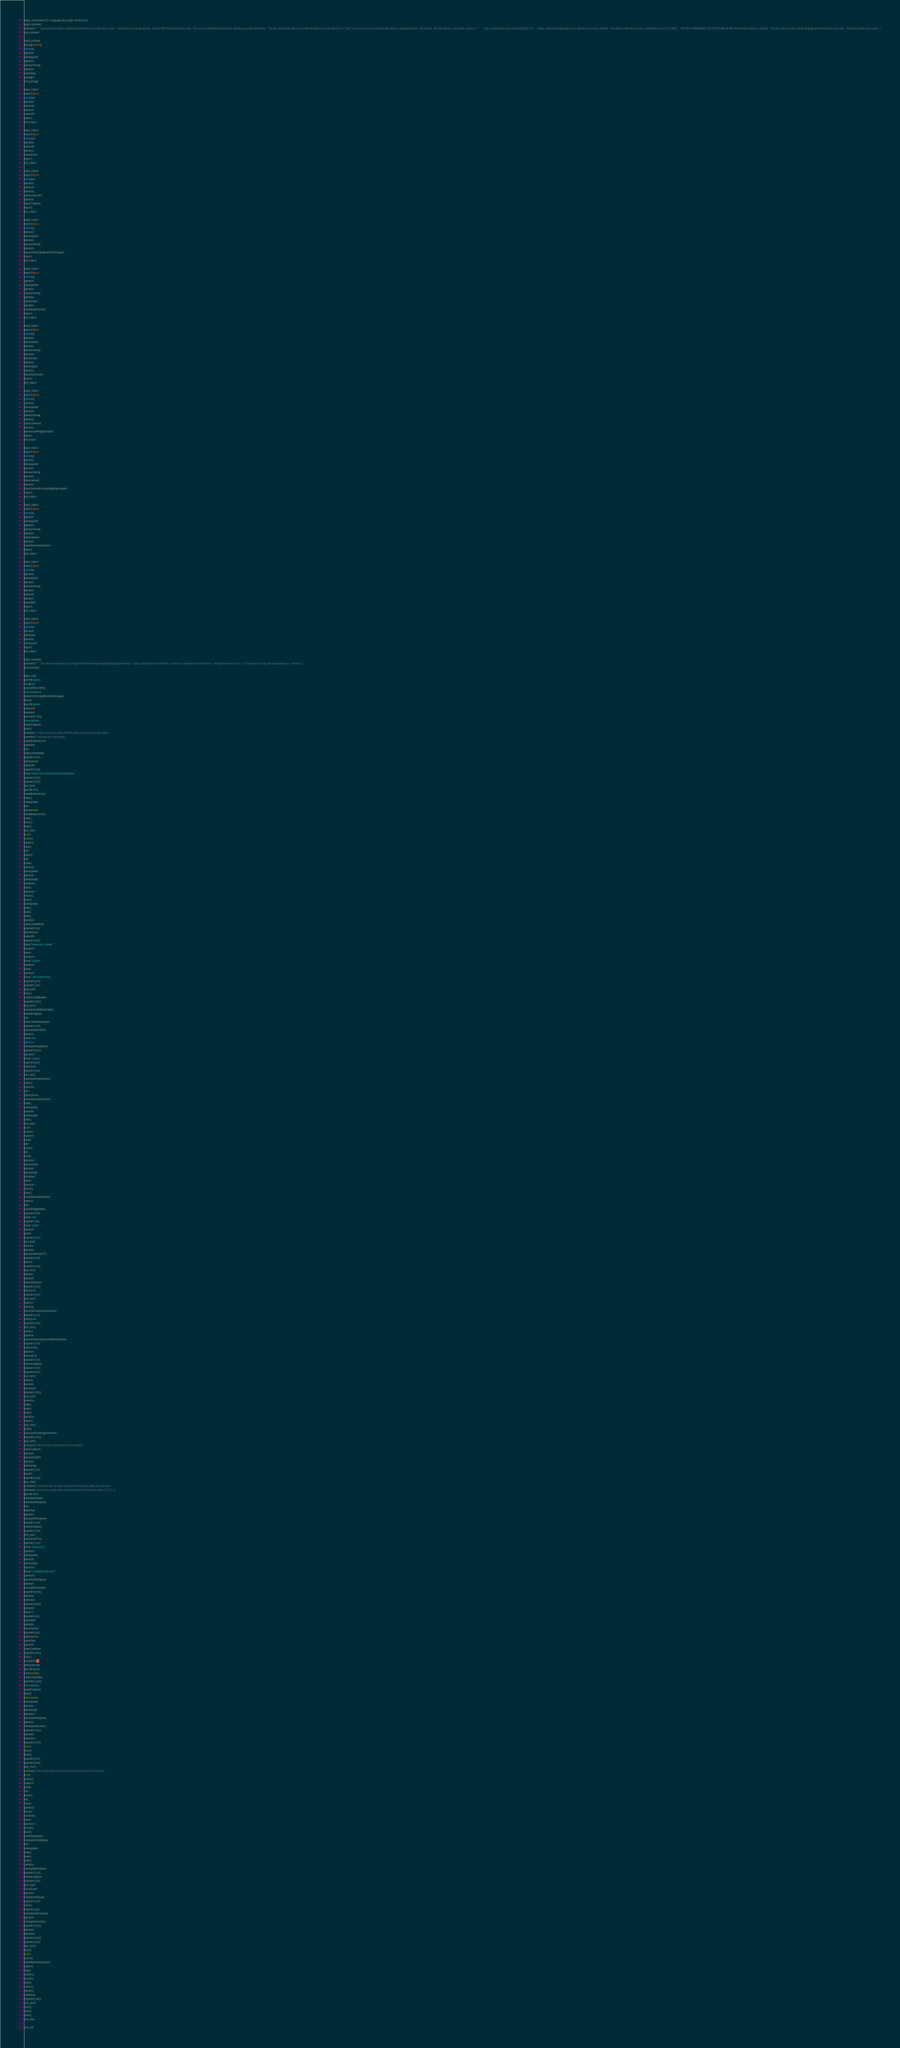Convert code to text. <code><loc_0><loc_0><loc_500><loc_500><_Java_>begin_unit|revision:0.9.5;language:Java;cregit-version:0.0.1
begin_comment
comment|/**  * Licensed to the Apache Software Foundation (ASF) under one or more  * contributor license agreements.  See the NOTICE file distributed with  * this work for additional information regarding copyright ownership.  * The ASF licenses this file to You under the Apache License, Version 2.0  * (the "License"); you may not use this file except in compliance with  * the License.  You may obtain a copy of the License at  *  *      http://www.apache.org/licenses/LICENSE-2.0  *  * Unless required by applicable law or agreed to in writing, software  * distributed under the License is distributed on an "AS IS" BASIS,  * WITHOUT WARRANTIES OR CONDITIONS OF ANY KIND, either express or implied.  * See the License for the specific language governing permissions and  * limitations under the License.  */
end_comment

begin_package
package|package
name|org
operator|.
name|apache
operator|.
name|activemq
operator|.
name|bugs
package|;
end_package

begin_import
import|import
name|java
operator|.
name|net
operator|.
name|URI
import|;
end_import

begin_import
import|import
name|java
operator|.
name|util
operator|.
name|Arrays
import|;
end_import

begin_import
import|import
name|java
operator|.
name|util
operator|.
name|concurrent
operator|.
name|TimeUnit
import|;
end_import

begin_import
import|import
name|org
operator|.
name|apache
operator|.
name|activemq
operator|.
name|JmsMultipleBrokersTestSupport
import|;
end_import

begin_import
import|import
name|org
operator|.
name|apache
operator|.
name|activemq
operator|.
name|broker
operator|.
name|BrokerService
import|;
end_import

begin_import
import|import
name|org
operator|.
name|apache
operator|.
name|activemq
operator|.
name|broker
operator|.
name|region
operator|.
name|Destination
import|;
end_import

begin_import
import|import
name|org
operator|.
name|apache
operator|.
name|activemq
operator|.
name|command
operator|.
name|ActiveMQDestination
import|;
end_import

begin_import
import|import
name|org
operator|.
name|apache
operator|.
name|activemq
operator|.
name|network
operator|.
name|DemandForwardingBridgeSupport
import|;
end_import

begin_import
import|import
name|org
operator|.
name|apache
operator|.
name|activemq
operator|.
name|network
operator|.
name|NetworkConnector
import|;
end_import

begin_import
import|import
name|org
operator|.
name|apache
operator|.
name|activemq
operator|.
name|util
operator|.
name|Wait
import|;
end_import

begin_import
import|import
name|org
operator|.
name|junit
operator|.
name|Assert
import|;
end_import

begin_comment
comment|/**  * This test demonstrates a bug in {@link DemandForwardingBridgeSupport} whereby  * a static subscription from broker1 to broker2 is forwarded to broker3 even  * though the network TTL is 1. This results in duplicate subscriptions on  * broker3.  */
end_comment

begin_class
specifier|public
class|class
name|AMQ4148Test
extends|extends
name|JmsMultipleBrokersTestSupport
block|{
specifier|public
name|void
name|test
parameter_list|()
throws|throws
name|Exception
block|{
comment|// Create a hub-and-spoke network where each hub-spoke pair share
comment|// messages on a test queue.
name|BrokerService
name|hub
init|=
name|createBroker
argument_list|(
operator|new
name|URI
argument_list|(
literal|"broker:(vm://hub)/hub?persistent=false"
argument_list|)
argument_list|)
decl_stmt|;
specifier|final
name|BrokerService
index|[]
name|spokes
init|=
operator|new
name|BrokerService
index|[
literal|4
index|]
decl_stmt|;
for|for
control|(
name|int
name|i
init|=
literal|0
init|;
name|i
operator|<
name|spokes
operator|.
name|length
condition|;
name|i
operator|++
control|)
block|{
name|spokes
index|[
name|i
index|]
operator|=
name|createBroker
argument_list|(
operator|new
name|URI
argument_list|(
literal|"broker:(vm://spoke"
operator|+
name|i
operator|+
literal|")/spoke"
operator|+
name|i
operator|+
literal|"?persistent=false"
argument_list|)
argument_list|)
expr_stmt|;
block|}
name|startAllBrokers
argument_list|()
expr_stmt|;
name|ActiveMQDestination
name|testQueue
init|=
name|createDestination
argument_list|(
name|AMQ4148Test
operator|.
name|class
operator|.
name|getSimpleName
argument_list|()
operator|+
literal|".queue"
argument_list|,
literal|false
argument_list|)
decl_stmt|;
name|NetworkConnector
index|[]
name|ncs
init|=
operator|new
name|NetworkConnector
index|[
name|spokes
operator|.
name|length
index|]
decl_stmt|;
for|for
control|(
name|int
name|i
init|=
literal|0
init|;
name|i
operator|<
name|spokes
operator|.
name|length
condition|;
name|i
operator|++
control|)
block|{
name|NetworkConnector
name|nc
init|=
name|bridgeBrokers
argument_list|(
literal|"hub"
argument_list|,
literal|"spoke"
operator|+
name|i
argument_list|)
decl_stmt|;
name|nc
operator|.
name|setNetworkTTL
argument_list|(
literal|1
argument_list|)
expr_stmt|;
name|nc
operator|.
name|setDuplex
argument_list|(
literal|true
argument_list|)
expr_stmt|;
name|nc
operator|.
name|setConduitSubscriptions
argument_list|(
literal|false
argument_list|)
expr_stmt|;
name|nc
operator|.
name|setStaticallyIncludedDestinations
argument_list|(
name|Arrays
operator|.
name|asList
argument_list|(
name|testQueue
argument_list|)
argument_list|)
expr_stmt|;
name|nc
operator|.
name|start
argument_list|()
expr_stmt|;
name|ncs
index|[
name|i
index|]
operator|=
name|nc
expr_stmt|;
block|}
name|waitForBridgeFormation
argument_list|()
expr_stmt|;
comment|// Pause to allow subscriptions to be created.
name|TimeUnit
operator|.
name|SECONDS
operator|.
name|sleep
argument_list|(
literal|5
argument_list|)
expr_stmt|;
comment|// Verify that the hub has a subscription from each spoke, but that each
comment|// spoke has a single subscription from the hub (since the network TTL is 1).
specifier|final
name|Destination
name|hubTestQueue
init|=
name|hub
operator|.
name|getDestination
argument_list|(
name|testQueue
argument_list|)
decl_stmt|;
name|assertTrue
argument_list|(
literal|"Expecting {"
operator|+
name|spokes
operator|.
name|length
operator|+
literal|"} consumer but was {"
operator|+
name|hubTestQueue
operator|.
name|getConsumers
argument_list|()
operator|.
name|size
argument_list|()
operator|+
literal|"}"
argument_list|,
name|Wait
operator|.
name|waitFor
argument_list|(
operator|new
name|Wait
operator|.
name|Condition
argument_list|()
block|{
annotation|@
name|Override
specifier|public
name|boolean
name|isSatisified
parameter_list|()
throws|throws
name|Exception
block|{
return|return
name|spokes
operator|.
name|length
operator|==
name|hubTestQueue
operator|.
name|getConsumers
argument_list|()
operator|.
name|size
argument_list|()
return|;
block|}
block|}
argument_list|)
argument_list|)
expr_stmt|;
comment|// Now check each spoke has exactly one consumer on the Queue.
for|for
control|(
name|int
name|i
init|=
literal|0
init|;
name|i
operator|<
literal|4
condition|;
name|i
operator|++
control|)
block|{
name|Destination
name|spokeTestQueue
init|=
name|spokes
index|[
name|i
index|]
operator|.
name|getDestination
argument_list|(
name|testQueue
argument_list|)
decl_stmt|;
name|Assert
operator|.
name|assertEquals
argument_list|(
literal|1
argument_list|,
name|spokeTestQueue
operator|.
name|getConsumers
argument_list|()
operator|.
name|size
argument_list|()
argument_list|)
expr_stmt|;
block|}
for|for
control|(
name|NetworkConnector
name|nc
range|:
name|ncs
control|)
block|{
name|nc
operator|.
name|stop
argument_list|()
expr_stmt|;
block|}
block|}
block|}
end_class

end_unit

</code> 